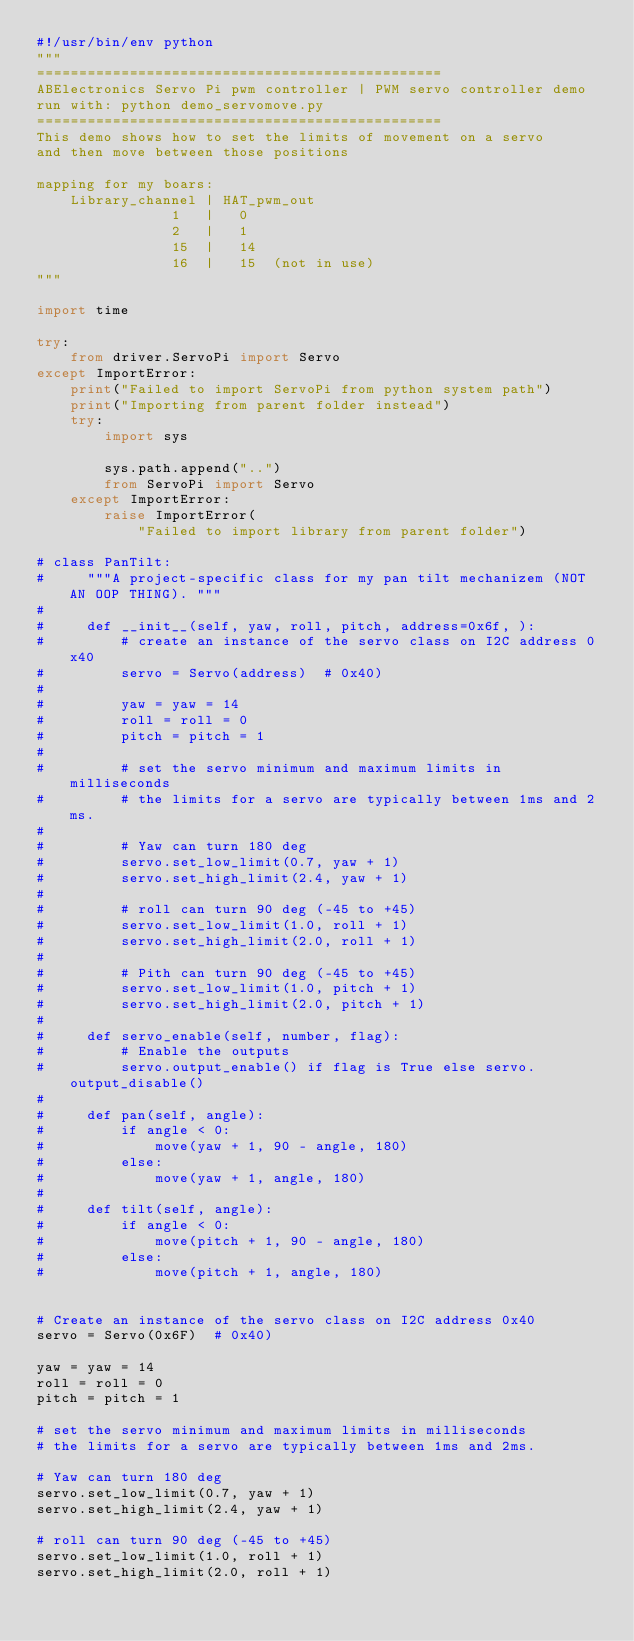Convert code to text. <code><loc_0><loc_0><loc_500><loc_500><_Python_>#!/usr/bin/env python
"""
================================================
ABElectronics Servo Pi pwm controller | PWM servo controller demo
run with: python demo_servomove.py
================================================
This demo shows how to set the limits of movement on a servo
and then move between those positions

mapping for my boars:
    Library_channel | HAT_pwm_out
                1   |   0
                2   |   1
                15  |   14
                16  |   15  (not in use)
"""

import time

try:
    from driver.ServoPi import Servo
except ImportError:
    print("Failed to import ServoPi from python system path")
    print("Importing from parent folder instead")
    try:
        import sys

        sys.path.append("..")
        from ServoPi import Servo
    except ImportError:
        raise ImportError(
            "Failed to import library from parent folder")

# class PanTilt:
#     """A project-specific class for my pan tilt mechanizem (NOT AN OOP THING). """
# 
#     def __init__(self, yaw, roll, pitch, address=0x6f, ):
#         # create an instance of the servo class on I2C address 0x40
#         servo = Servo(address)  # 0x40)
# 
#         yaw = yaw = 14
#         roll = roll = 0
#         pitch = pitch = 1
# 
#         # set the servo minimum and maximum limits in milliseconds
#         # the limits for a servo are typically between 1ms and 2ms.
# 
#         # Yaw can turn 180 deg
#         servo.set_low_limit(0.7, yaw + 1)
#         servo.set_high_limit(2.4, yaw + 1)
# 
#         # roll can turn 90 deg (-45 to +45)
#         servo.set_low_limit(1.0, roll + 1)
#         servo.set_high_limit(2.0, roll + 1)
# 
#         # Pith can turn 90 deg (-45 to +45)
#         servo.set_low_limit(1.0, pitch + 1)
#         servo.set_high_limit(2.0, pitch + 1)
# 
#     def servo_enable(self, number, flag):
#         # Enable the outputs
#         servo.output_enable() if flag is True else servo.output_disable()
# 
#     def pan(self, angle):
#         if angle < 0:
#             move(yaw + 1, 90 - angle, 180)
#         else:
#             move(yaw + 1, angle, 180)
# 
#     def tilt(self, angle):
#         if angle < 0:
#             move(pitch + 1, 90 - angle, 180)
#         else:
#             move(pitch + 1, angle, 180)


# Create an instance of the servo class on I2C address 0x40
servo = Servo(0x6F)  # 0x40)

yaw = yaw = 14
roll = roll = 0
pitch = pitch = 1

# set the servo minimum and maximum limits in milliseconds
# the limits for a servo are typically between 1ms and 2ms.

# Yaw can turn 180 deg
servo.set_low_limit(0.7, yaw + 1)
servo.set_high_limit(2.4, yaw + 1)

# roll can turn 90 deg (-45 to +45)
servo.set_low_limit(1.0, roll + 1)
servo.set_high_limit(2.0, roll + 1)
</code> 